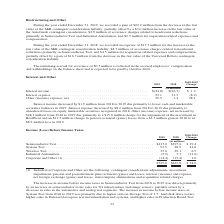According to Teradyne's financial document, What is included in Corporate and Other? contingent consideration adjustments, investment impairment, pension and postretirement plans actuarial (gains) and losses, interest (income) and expense, net foreign exchange (gains) and losses, intercompany eliminations and acquisition related charges.. The document states: "Included in Corporate and Other are the following: contingent consideration adjustments, investment impairment, pension and postretirement plans actua..." Also, What was the increase in income before income taxes in Semiconductor Test driven by? by an increase in semiconductor tester sales for 5G infrastructure and image sensors, partially offset by a decrease in sales in the automotive and analog test segments.. The document states: "ductor Test from 2018 to 2019 was driven primarily by an increase in semiconductor tester sales for 5G infrastructure and image sensors, partially off..." Also, What are the segments considered under income (loss) before income taxes in the table? The document contains multiple relevant values: Semiconductor Test, System Test, Wireless Test, Industrial Automation, Corporate and Other. From the document: "llions) Semiconductor Test . $417.0 $397.6 $ 19.4 System Test . 93.5 48.9 44.6 Wireless Test . 35.6 29.1 6.5 Industrial Automation . (5.9) 7.7 (13.6) ..." Additionally, In which year was the amount for Wireless Test the largest? According to the financial document, 2019. The relevant text states: "During the year ended December 31, 2019, we recorded a gain of $22.2 million from the decrease in the fair value of the MiR contingent cons..." Also, can you calculate: What was the percentage change in Wireless Test in 2019 from 2018? To answer this question, I need to perform calculations using the financial data. The calculation is: (35.6-29.1)/29.1, which equals 22.34 (percentage). This is based on the information: "19.4 System Test . 93.5 48.9 44.6 Wireless Test . 35.6 29.1 6.5 Industrial Automation . (5.9) 7.7 (13.6) Corporate and Other (1) . (14.4) (15.4) 1.0 System Test . 93.5 48.9 44.6 Wireless Test . 35.6 2..." The key data points involved are: 29.1, 35.6. Also, can you calculate: What was the percentage change in System Test in 2019 from 2018? To answer this question, I need to perform calculations using the financial data. The calculation is: (93.5-48.9)/48.9, which equals 91.21 (percentage). This is based on the information: "or Test . $417.0 $397.6 $ 19.4 System Test . 93.5 48.9 44.6 Wireless Test . 35.6 29.1 6.5 Industrial Automation . (5.9) 7.7 (13.6) Corporate and Other (1) nductor Test . $417.0 $397.6 $ 19.4 System Te..." The key data points involved are: 48.9, 93.5. 